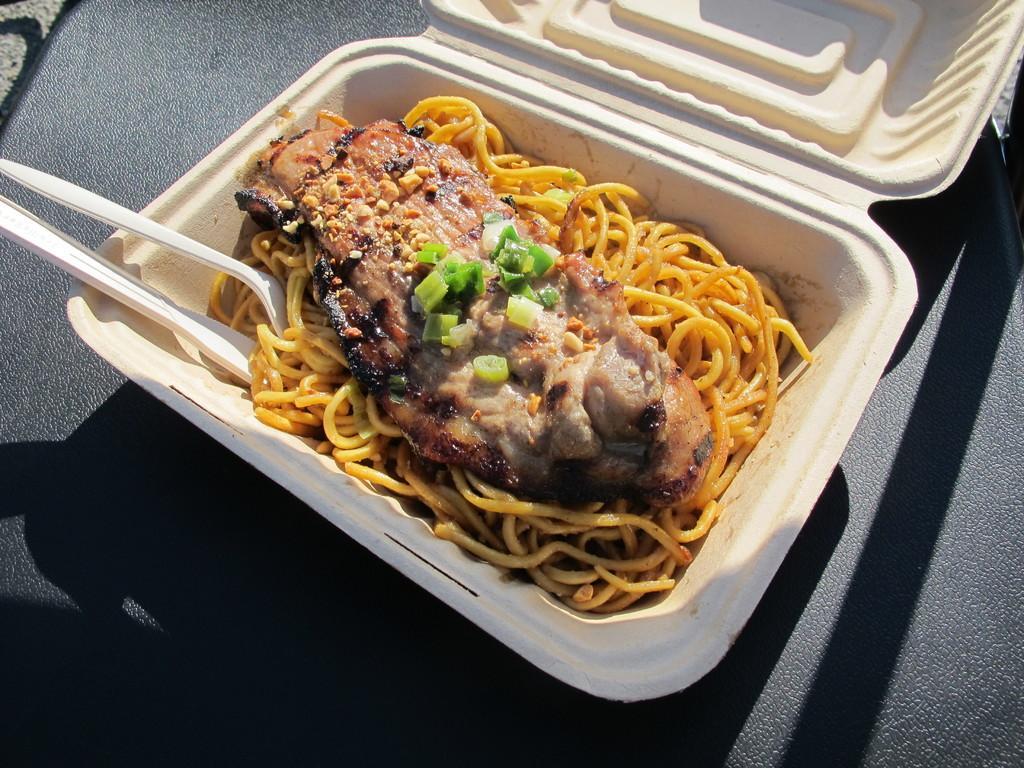Describe this image in one or two sentences. In this image I can see a white color box which consists of some food and spoons. The background seems to be a seat. 